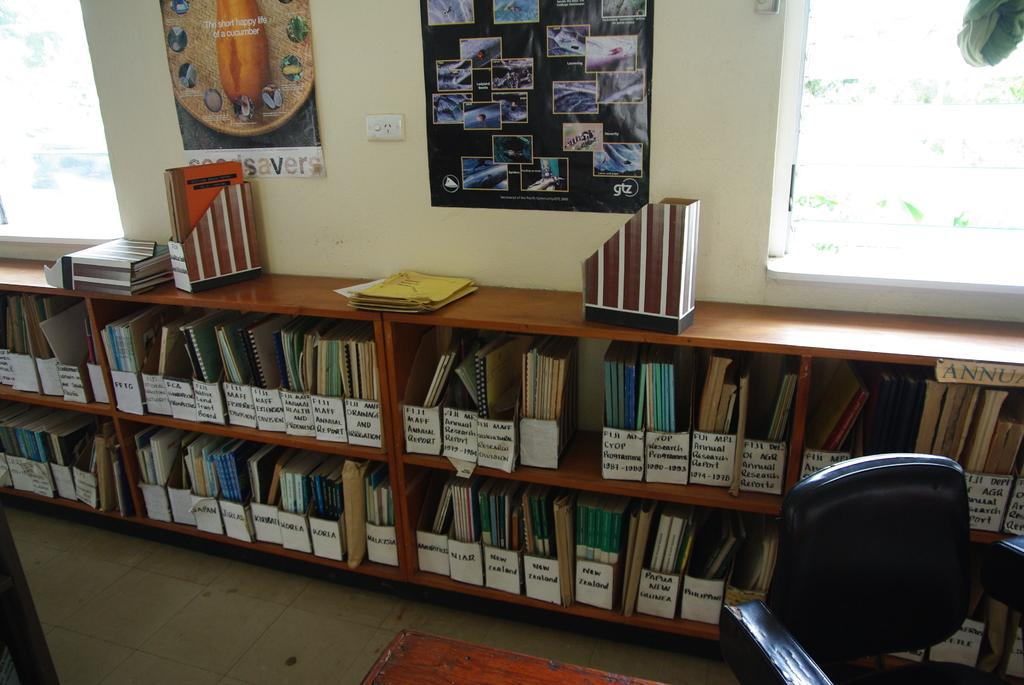<image>
Give a short and clear explanation of the subsequent image. shelves of binded papers in a room with posters that have the letters GTZ on it 